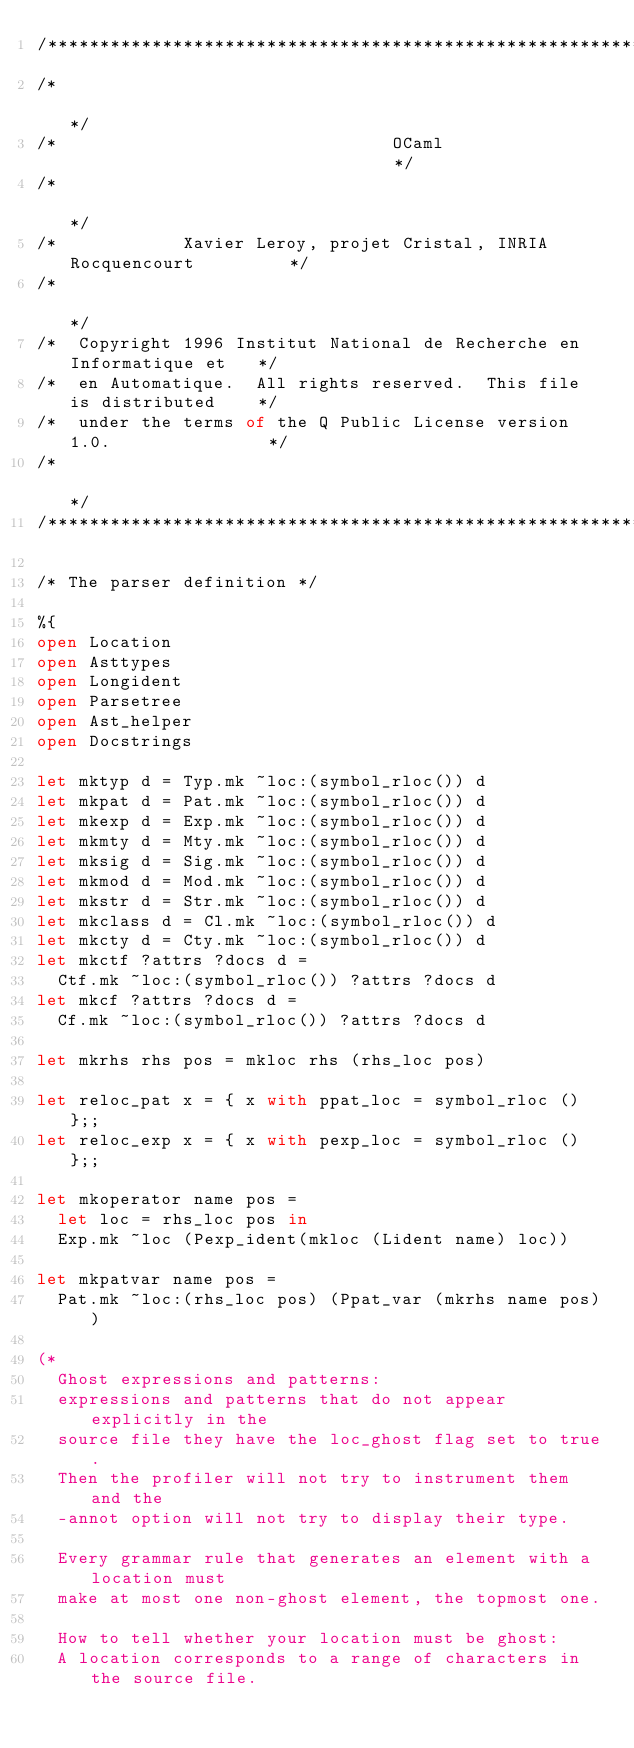Convert code to text. <code><loc_0><loc_0><loc_500><loc_500><_OCaml_>/***********************************************************************/
/*                                                                     */
/*                                OCaml                                */
/*                                                                     */
/*            Xavier Leroy, projet Cristal, INRIA Rocquencourt         */
/*                                                                     */
/*  Copyright 1996 Institut National de Recherche en Informatique et   */
/*  en Automatique.  All rights reserved.  This file is distributed    */
/*  under the terms of the Q Public License version 1.0.               */
/*                                                                     */
/***********************************************************************/

/* The parser definition */

%{
open Location
open Asttypes
open Longident
open Parsetree
open Ast_helper
open Docstrings

let mktyp d = Typ.mk ~loc:(symbol_rloc()) d
let mkpat d = Pat.mk ~loc:(symbol_rloc()) d
let mkexp d = Exp.mk ~loc:(symbol_rloc()) d
let mkmty d = Mty.mk ~loc:(symbol_rloc()) d
let mksig d = Sig.mk ~loc:(symbol_rloc()) d
let mkmod d = Mod.mk ~loc:(symbol_rloc()) d
let mkstr d = Str.mk ~loc:(symbol_rloc()) d
let mkclass d = Cl.mk ~loc:(symbol_rloc()) d
let mkcty d = Cty.mk ~loc:(symbol_rloc()) d
let mkctf ?attrs ?docs d =
  Ctf.mk ~loc:(symbol_rloc()) ?attrs ?docs d
let mkcf ?attrs ?docs d =
  Cf.mk ~loc:(symbol_rloc()) ?attrs ?docs d

let mkrhs rhs pos = mkloc rhs (rhs_loc pos)

let reloc_pat x = { x with ppat_loc = symbol_rloc () };;
let reloc_exp x = { x with pexp_loc = symbol_rloc () };;

let mkoperator name pos =
  let loc = rhs_loc pos in
  Exp.mk ~loc (Pexp_ident(mkloc (Lident name) loc))

let mkpatvar name pos =
  Pat.mk ~loc:(rhs_loc pos) (Ppat_var (mkrhs name pos))

(*
  Ghost expressions and patterns:
  expressions and patterns that do not appear explicitly in the
  source file they have the loc_ghost flag set to true.
  Then the profiler will not try to instrument them and the
  -annot option will not try to display their type.

  Every grammar rule that generates an element with a location must
  make at most one non-ghost element, the topmost one.

  How to tell whether your location must be ghost:
  A location corresponds to a range of characters in the source file.</code> 